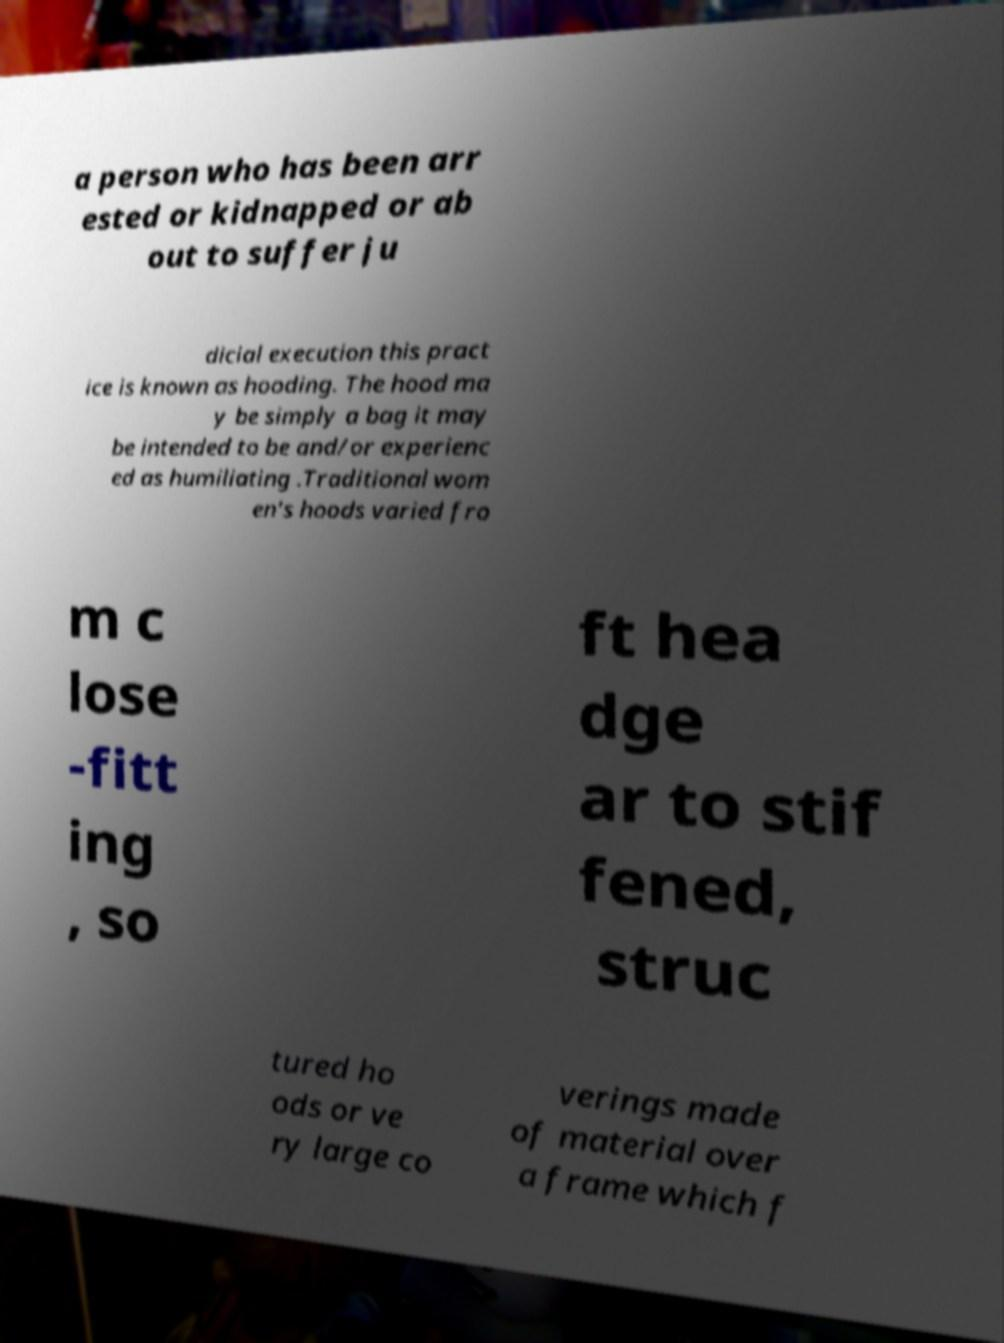I need the written content from this picture converted into text. Can you do that? a person who has been arr ested or kidnapped or ab out to suffer ju dicial execution this pract ice is known as hooding. The hood ma y be simply a bag it may be intended to be and/or experienc ed as humiliating .Traditional wom en's hoods varied fro m c lose -fitt ing , so ft hea dge ar to stif fened, struc tured ho ods or ve ry large co verings made of material over a frame which f 